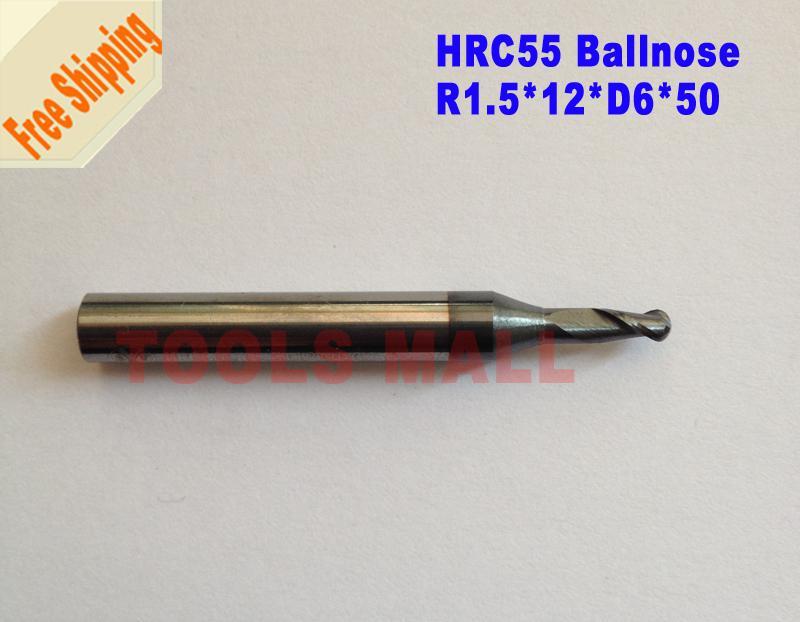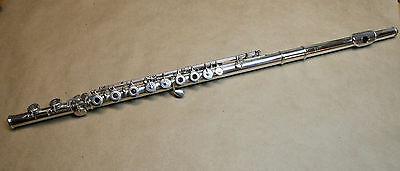The first image is the image on the left, the second image is the image on the right. Evaluate the accuracy of this statement regarding the images: "Exactly two mouthpieces are visible.". Is it true? Answer yes or no. No. 